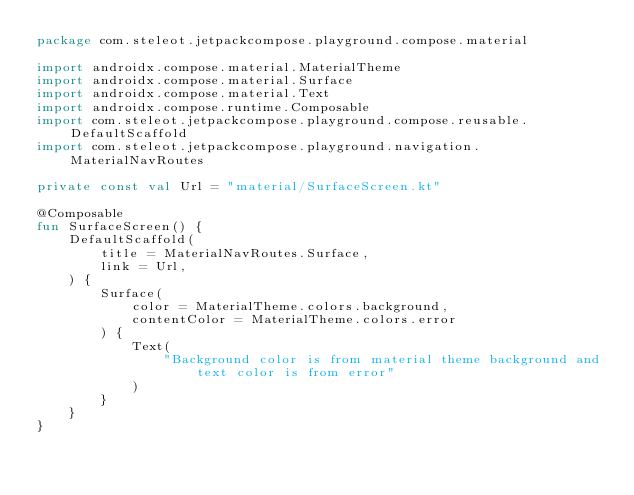Convert code to text. <code><loc_0><loc_0><loc_500><loc_500><_Kotlin_>package com.steleot.jetpackcompose.playground.compose.material

import androidx.compose.material.MaterialTheme
import androidx.compose.material.Surface
import androidx.compose.material.Text
import androidx.compose.runtime.Composable
import com.steleot.jetpackcompose.playground.compose.reusable.DefaultScaffold
import com.steleot.jetpackcompose.playground.navigation.MaterialNavRoutes

private const val Url = "material/SurfaceScreen.kt"

@Composable
fun SurfaceScreen() {
    DefaultScaffold(
        title = MaterialNavRoutes.Surface,
        link = Url,
    ) {
        Surface(
            color = MaterialTheme.colors.background,
            contentColor = MaterialTheme.colors.error
        ) {
            Text(
                "Background color is from material theme background and text color is from error"
            )
        }
    }
}</code> 